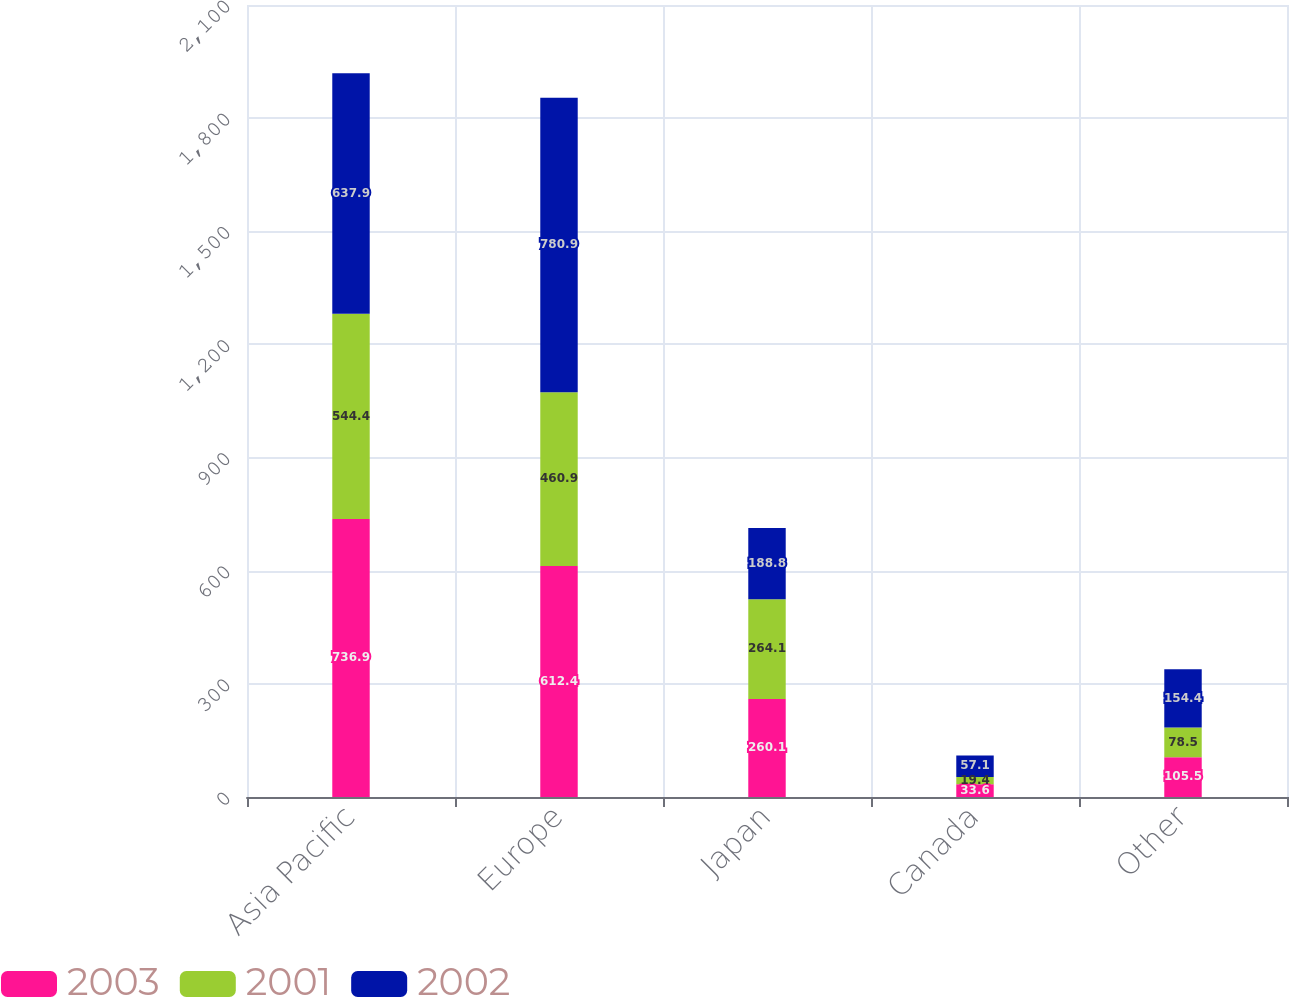Convert chart. <chart><loc_0><loc_0><loc_500><loc_500><stacked_bar_chart><ecel><fcel>Asia Pacific<fcel>Europe<fcel>Japan<fcel>Canada<fcel>Other<nl><fcel>2003<fcel>736.9<fcel>612.4<fcel>260.1<fcel>33.6<fcel>105.5<nl><fcel>2001<fcel>544.4<fcel>460.9<fcel>264.1<fcel>19.4<fcel>78.5<nl><fcel>2002<fcel>637.9<fcel>780.9<fcel>188.8<fcel>57.1<fcel>154.4<nl></chart> 